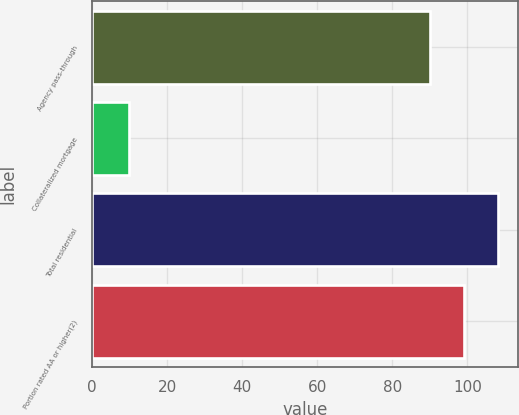Convert chart to OTSL. <chart><loc_0><loc_0><loc_500><loc_500><bar_chart><fcel>Agency pass-through<fcel>Collateralized mortgage<fcel>Total residential<fcel>Portion rated AA or higher(2)<nl><fcel>90.1<fcel>9.9<fcel>108.12<fcel>99.11<nl></chart> 